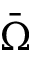Convert formula to latex. <formula><loc_0><loc_0><loc_500><loc_500>\bar { \Omega }</formula> 